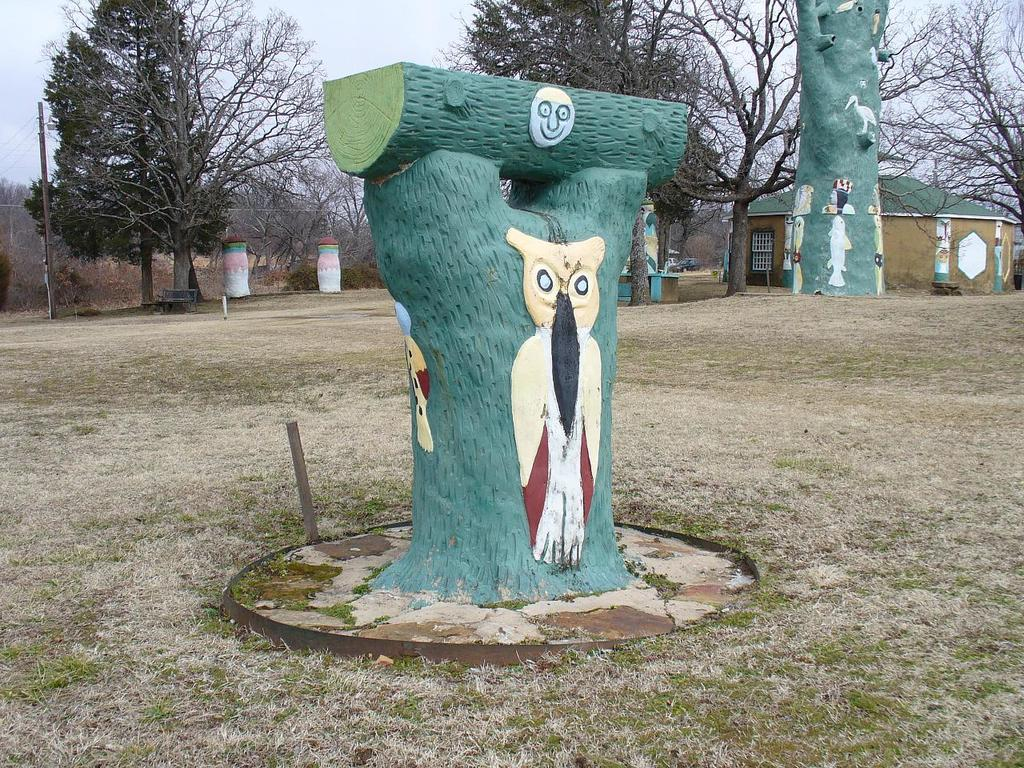What is painted on the tree trunks in the image? There are paintings on the tree trunks in the image. What type of structure can be seen in the image? There is a house in the image. What type of barrier is present in the image? There is a wire fence in the image. What type of vegetation is present in the image? There is grass in the image. What type of natural feature is present in the image? There are trees in the image. What is visible in the background of the image? The sky is visible in the background of the image. Reasoning: Let' Let's think step by step in order to produce the conversation. We start by identifying the main subjects and objects in the image based on the provided facts. We then formulate questions that focus on the location and characteristics of these subjects and objects, ensuring that each question can be answered definitively with the information given. We avoid yes/no questions and ensure that the language is simple and clear. Absurd Question/Answer: How does the temper of the grass affect the growth of the trees in the image? There is no indication of the grass's temper in the image, and the growth of the trees is not affected by it. What type of utensil is used to eat the fork in the image? There is no fork present in the image. 